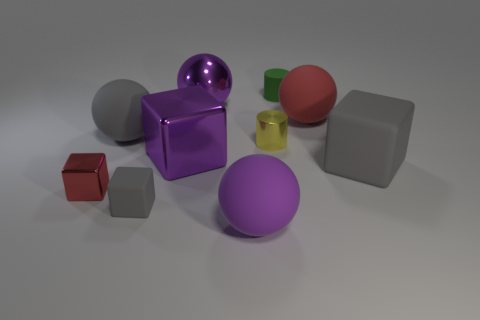Subtract all purple metal cubes. How many cubes are left? 3 Subtract all yellow cylinders. How many gray cubes are left? 2 Subtract all gray spheres. How many spheres are left? 3 Subtract 4 blocks. How many blocks are left? 0 Add 3 small yellow metallic objects. How many small yellow metallic objects are left? 4 Add 7 gray objects. How many gray objects exist? 10 Subtract 0 blue cylinders. How many objects are left? 10 Subtract all cylinders. How many objects are left? 8 Subtract all yellow balls. Subtract all yellow cylinders. How many balls are left? 4 Subtract all big purple cubes. Subtract all large metallic objects. How many objects are left? 7 